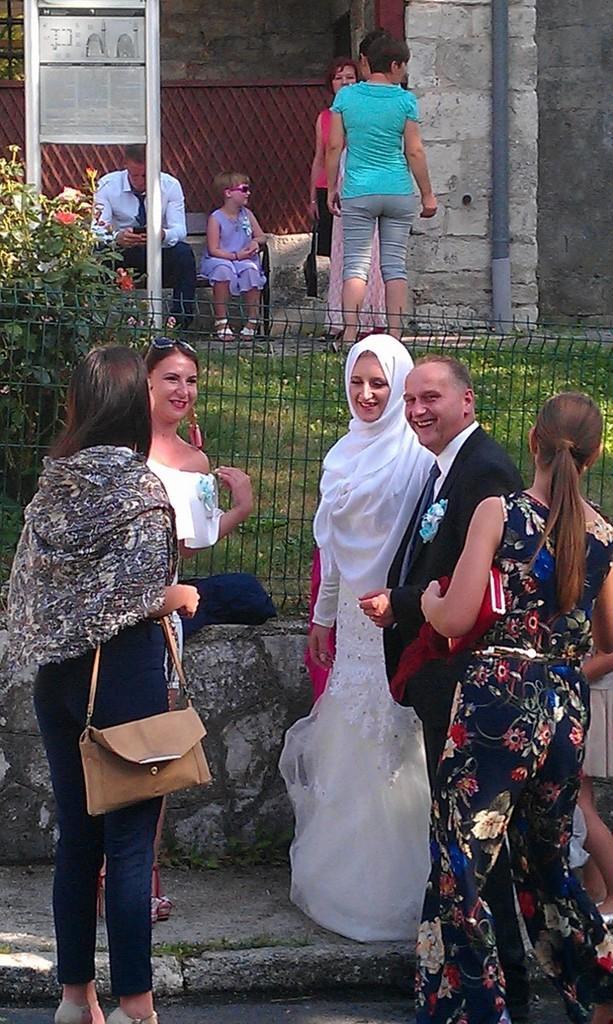Can you describe this image briefly? In the bottom of the image, there are five persons standing. In the top of the image middle, there are four persons. Two of them are standing and two of them are sitting on the bench. In the background, there is a wall of cement stones. In front of that there is a board. In the middle of the background, there is a grass of green in color and rose plants. This image is taken on the road side during day time. 